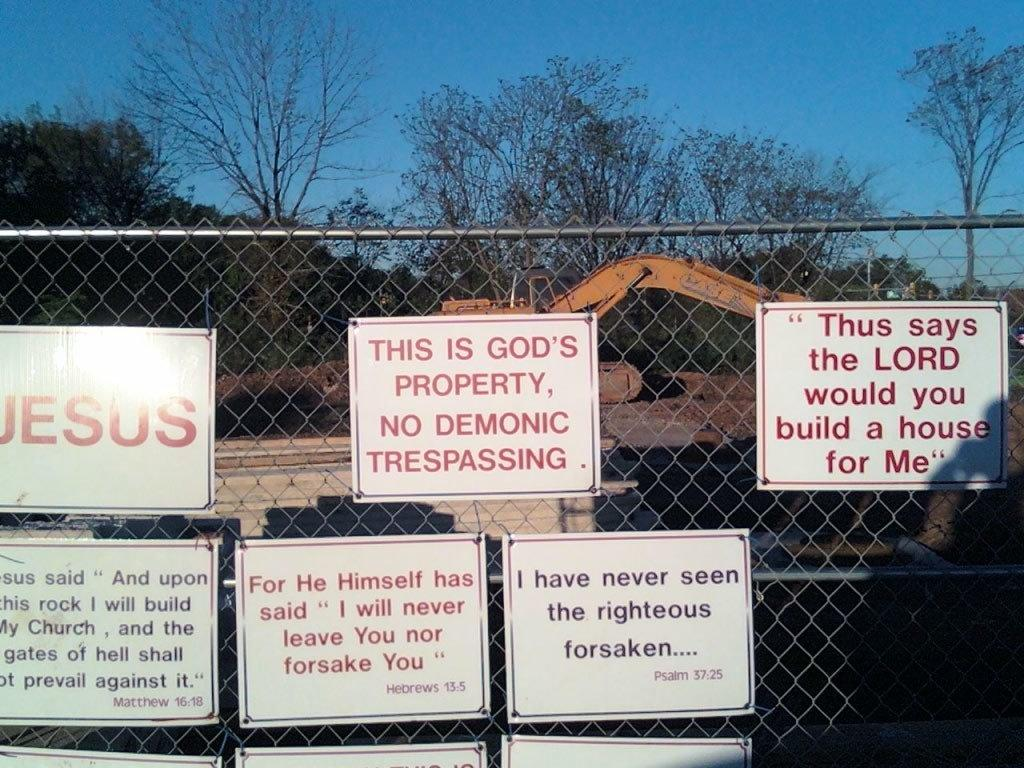<image>
Render a clear and concise summary of the photo. The top left sign on the gate says "JESUS." 